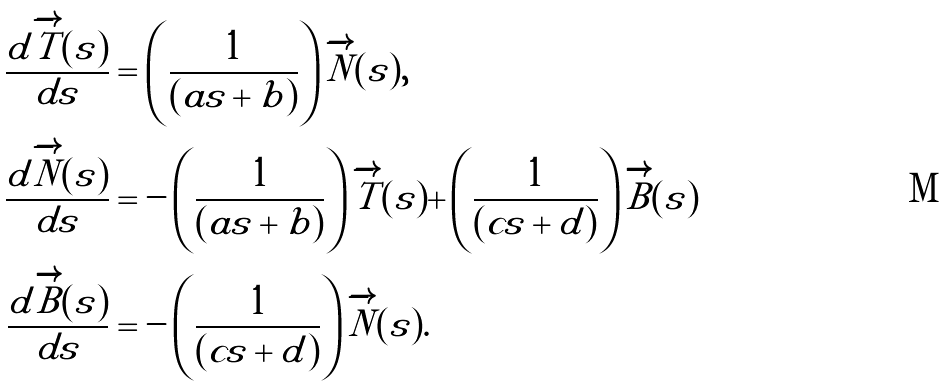<formula> <loc_0><loc_0><loc_500><loc_500>\frac { d \overrightarrow { T } ( s ) } { d s } & = \left ( \frac { 1 } { ( a s + b ) } \right ) \overrightarrow { N } ( s ) , \\ \frac { d \overrightarrow { N } ( s ) } { d s } & = - \left ( \frac { 1 } { ( a s + b ) } \right ) \overrightarrow { T } ( s ) + \left ( \frac { 1 } { ( c s + d ) } \right ) \overrightarrow { B } ( s ) \\ \frac { d \overrightarrow { B } ( s ) } { d s } & = - \left ( \frac { 1 } { ( c s + d ) } \right ) \overrightarrow { N } ( s ) .</formula> 